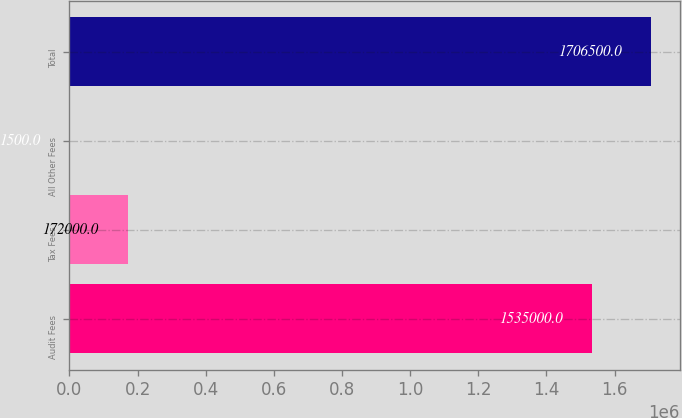<chart> <loc_0><loc_0><loc_500><loc_500><bar_chart><fcel>Audit Fees<fcel>Tax Fees<fcel>All Other Fees<fcel>Total<nl><fcel>1.535e+06<fcel>172000<fcel>1500<fcel>1.7065e+06<nl></chart> 